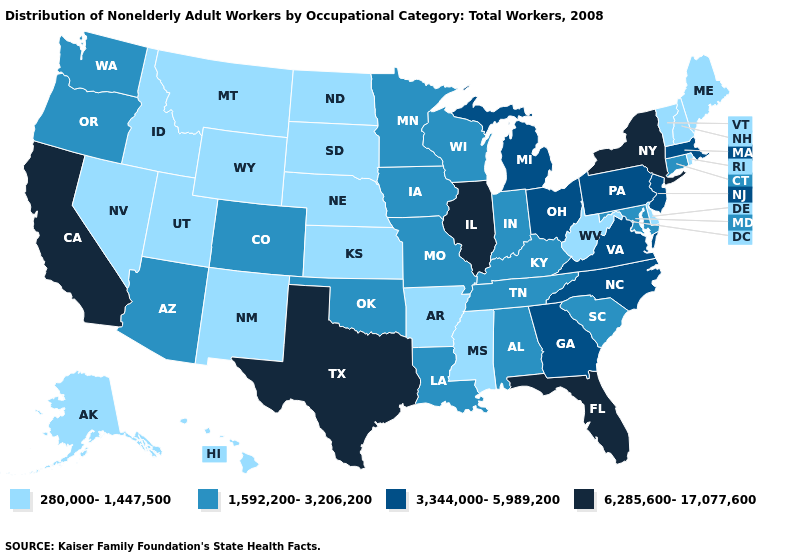Name the states that have a value in the range 3,344,000-5,989,200?
Concise answer only. Georgia, Massachusetts, Michigan, New Jersey, North Carolina, Ohio, Pennsylvania, Virginia. What is the value of Maine?
Give a very brief answer. 280,000-1,447,500. What is the lowest value in states that border Nebraska?
Write a very short answer. 280,000-1,447,500. Does Mississippi have the lowest value in the USA?
Concise answer only. Yes. Does Georgia have a higher value than Vermont?
Be succinct. Yes. Name the states that have a value in the range 6,285,600-17,077,600?
Answer briefly. California, Florida, Illinois, New York, Texas. Does Illinois have the highest value in the USA?
Give a very brief answer. Yes. Name the states that have a value in the range 1,592,200-3,206,200?
Answer briefly. Alabama, Arizona, Colorado, Connecticut, Indiana, Iowa, Kentucky, Louisiana, Maryland, Minnesota, Missouri, Oklahoma, Oregon, South Carolina, Tennessee, Washington, Wisconsin. Name the states that have a value in the range 3,344,000-5,989,200?
Be succinct. Georgia, Massachusetts, Michigan, New Jersey, North Carolina, Ohio, Pennsylvania, Virginia. Name the states that have a value in the range 3,344,000-5,989,200?
Concise answer only. Georgia, Massachusetts, Michigan, New Jersey, North Carolina, Ohio, Pennsylvania, Virginia. Name the states that have a value in the range 6,285,600-17,077,600?
Give a very brief answer. California, Florida, Illinois, New York, Texas. Name the states that have a value in the range 6,285,600-17,077,600?
Write a very short answer. California, Florida, Illinois, New York, Texas. What is the lowest value in the South?
Be succinct. 280,000-1,447,500. Does New Hampshire have the highest value in the USA?
Quick response, please. No. What is the value of South Dakota?
Short answer required. 280,000-1,447,500. 